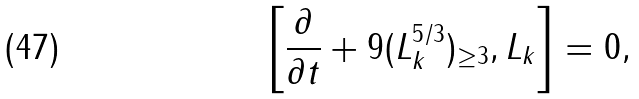Convert formula to latex. <formula><loc_0><loc_0><loc_500><loc_500>\left [ \frac { \partial } { \partial t } + 9 ( L _ { k } ^ { 5 / 3 } ) _ { \geq 3 } , L _ { k } \right ] = 0 ,</formula> 